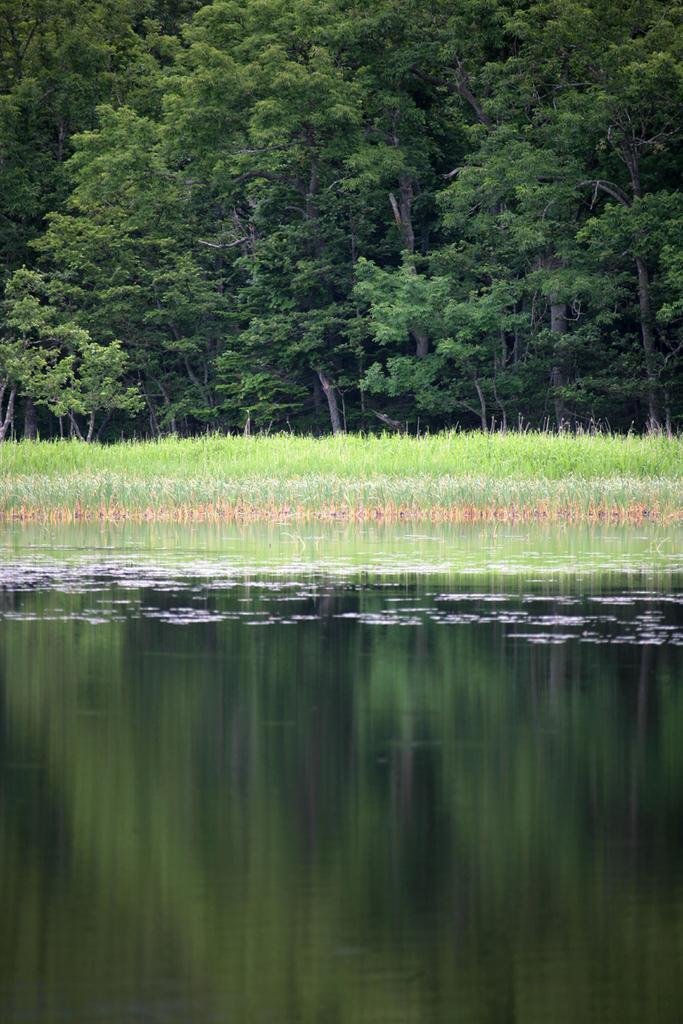How would you summarize this image in a sentence or two? In the center of the image there is water. At the background of the image there is grass and trees. 